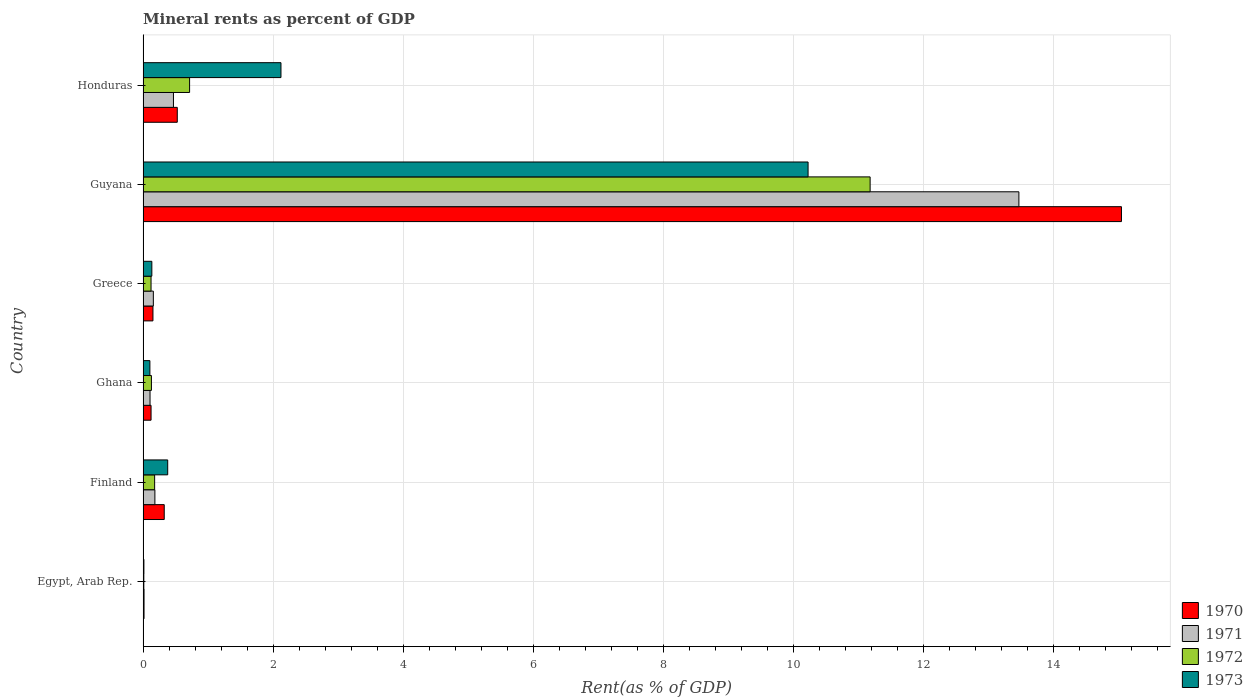How many groups of bars are there?
Make the answer very short. 6. Are the number of bars per tick equal to the number of legend labels?
Your response must be concise. Yes. How many bars are there on the 5th tick from the top?
Provide a short and direct response. 4. What is the label of the 5th group of bars from the top?
Provide a short and direct response. Finland. In how many cases, is the number of bars for a given country not equal to the number of legend labels?
Offer a very short reply. 0. What is the mineral rent in 1971 in Ghana?
Your response must be concise. 0.11. Across all countries, what is the maximum mineral rent in 1972?
Your response must be concise. 11.18. Across all countries, what is the minimum mineral rent in 1973?
Your answer should be very brief. 0.01. In which country was the mineral rent in 1970 maximum?
Ensure brevity in your answer.  Guyana. In which country was the mineral rent in 1970 minimum?
Offer a terse response. Egypt, Arab Rep. What is the total mineral rent in 1972 in the graph?
Your answer should be compact. 12.34. What is the difference between the mineral rent in 1972 in Finland and that in Guyana?
Provide a succinct answer. -11. What is the difference between the mineral rent in 1972 in Guyana and the mineral rent in 1973 in Honduras?
Offer a terse response. 9.06. What is the average mineral rent in 1971 per country?
Your answer should be very brief. 2.4. What is the difference between the mineral rent in 1972 and mineral rent in 1970 in Honduras?
Provide a succinct answer. 0.19. In how many countries, is the mineral rent in 1972 greater than 9.2 %?
Offer a very short reply. 1. What is the ratio of the mineral rent in 1970 in Egypt, Arab Rep. to that in Ghana?
Your answer should be compact. 0.12. Is the difference between the mineral rent in 1972 in Guyana and Honduras greater than the difference between the mineral rent in 1970 in Guyana and Honduras?
Keep it short and to the point. No. What is the difference between the highest and the second highest mineral rent in 1973?
Provide a succinct answer. 8.11. What is the difference between the highest and the lowest mineral rent in 1972?
Your answer should be compact. 11.17. Is it the case that in every country, the sum of the mineral rent in 1970 and mineral rent in 1971 is greater than the sum of mineral rent in 1973 and mineral rent in 1972?
Offer a terse response. No. Is it the case that in every country, the sum of the mineral rent in 1972 and mineral rent in 1971 is greater than the mineral rent in 1970?
Keep it short and to the point. Yes. Are all the bars in the graph horizontal?
Offer a very short reply. Yes. Does the graph contain any zero values?
Make the answer very short. No. What is the title of the graph?
Your answer should be compact. Mineral rents as percent of GDP. Does "1966" appear as one of the legend labels in the graph?
Keep it short and to the point. No. What is the label or title of the X-axis?
Your answer should be compact. Rent(as % of GDP). What is the Rent(as % of GDP) of 1970 in Egypt, Arab Rep.?
Ensure brevity in your answer.  0.01. What is the Rent(as % of GDP) in 1971 in Egypt, Arab Rep.?
Offer a very short reply. 0.02. What is the Rent(as % of GDP) in 1972 in Egypt, Arab Rep.?
Your answer should be compact. 0.01. What is the Rent(as % of GDP) in 1973 in Egypt, Arab Rep.?
Your response must be concise. 0.01. What is the Rent(as % of GDP) of 1970 in Finland?
Offer a terse response. 0.33. What is the Rent(as % of GDP) of 1971 in Finland?
Provide a succinct answer. 0.18. What is the Rent(as % of GDP) of 1972 in Finland?
Ensure brevity in your answer.  0.18. What is the Rent(as % of GDP) in 1973 in Finland?
Offer a very short reply. 0.38. What is the Rent(as % of GDP) of 1970 in Ghana?
Your answer should be compact. 0.12. What is the Rent(as % of GDP) of 1971 in Ghana?
Offer a terse response. 0.11. What is the Rent(as % of GDP) of 1972 in Ghana?
Offer a terse response. 0.13. What is the Rent(as % of GDP) in 1973 in Ghana?
Offer a terse response. 0.1. What is the Rent(as % of GDP) in 1970 in Greece?
Your answer should be compact. 0.15. What is the Rent(as % of GDP) of 1971 in Greece?
Offer a terse response. 0.16. What is the Rent(as % of GDP) of 1972 in Greece?
Keep it short and to the point. 0.12. What is the Rent(as % of GDP) of 1973 in Greece?
Your response must be concise. 0.13. What is the Rent(as % of GDP) in 1970 in Guyana?
Your answer should be compact. 15.05. What is the Rent(as % of GDP) of 1971 in Guyana?
Your answer should be very brief. 13.47. What is the Rent(as % of GDP) in 1972 in Guyana?
Your response must be concise. 11.18. What is the Rent(as % of GDP) of 1973 in Guyana?
Ensure brevity in your answer.  10.23. What is the Rent(as % of GDP) in 1970 in Honduras?
Your answer should be compact. 0.53. What is the Rent(as % of GDP) in 1971 in Honduras?
Provide a short and direct response. 0.47. What is the Rent(as % of GDP) of 1972 in Honduras?
Provide a short and direct response. 0.72. What is the Rent(as % of GDP) in 1973 in Honduras?
Give a very brief answer. 2.12. Across all countries, what is the maximum Rent(as % of GDP) of 1970?
Give a very brief answer. 15.05. Across all countries, what is the maximum Rent(as % of GDP) of 1971?
Provide a succinct answer. 13.47. Across all countries, what is the maximum Rent(as % of GDP) of 1972?
Provide a short and direct response. 11.18. Across all countries, what is the maximum Rent(as % of GDP) in 1973?
Offer a very short reply. 10.23. Across all countries, what is the minimum Rent(as % of GDP) in 1970?
Offer a terse response. 0.01. Across all countries, what is the minimum Rent(as % of GDP) in 1971?
Give a very brief answer. 0.02. Across all countries, what is the minimum Rent(as % of GDP) in 1972?
Provide a short and direct response. 0.01. Across all countries, what is the minimum Rent(as % of GDP) in 1973?
Offer a very short reply. 0.01. What is the total Rent(as % of GDP) of 1970 in the graph?
Offer a very short reply. 16.19. What is the total Rent(as % of GDP) of 1971 in the graph?
Offer a very short reply. 14.4. What is the total Rent(as % of GDP) of 1972 in the graph?
Give a very brief answer. 12.34. What is the total Rent(as % of GDP) in 1973 in the graph?
Ensure brevity in your answer.  12.98. What is the difference between the Rent(as % of GDP) in 1970 in Egypt, Arab Rep. and that in Finland?
Offer a terse response. -0.31. What is the difference between the Rent(as % of GDP) of 1971 in Egypt, Arab Rep. and that in Finland?
Offer a very short reply. -0.17. What is the difference between the Rent(as % of GDP) of 1972 in Egypt, Arab Rep. and that in Finland?
Give a very brief answer. -0.17. What is the difference between the Rent(as % of GDP) of 1973 in Egypt, Arab Rep. and that in Finland?
Your response must be concise. -0.37. What is the difference between the Rent(as % of GDP) in 1970 in Egypt, Arab Rep. and that in Ghana?
Your response must be concise. -0.11. What is the difference between the Rent(as % of GDP) of 1971 in Egypt, Arab Rep. and that in Ghana?
Provide a short and direct response. -0.09. What is the difference between the Rent(as % of GDP) in 1972 in Egypt, Arab Rep. and that in Ghana?
Provide a short and direct response. -0.12. What is the difference between the Rent(as % of GDP) in 1973 in Egypt, Arab Rep. and that in Ghana?
Make the answer very short. -0.09. What is the difference between the Rent(as % of GDP) in 1970 in Egypt, Arab Rep. and that in Greece?
Your answer should be compact. -0.14. What is the difference between the Rent(as % of GDP) in 1971 in Egypt, Arab Rep. and that in Greece?
Give a very brief answer. -0.14. What is the difference between the Rent(as % of GDP) in 1972 in Egypt, Arab Rep. and that in Greece?
Your response must be concise. -0.11. What is the difference between the Rent(as % of GDP) of 1973 in Egypt, Arab Rep. and that in Greece?
Make the answer very short. -0.12. What is the difference between the Rent(as % of GDP) in 1970 in Egypt, Arab Rep. and that in Guyana?
Provide a succinct answer. -15.03. What is the difference between the Rent(as % of GDP) of 1971 in Egypt, Arab Rep. and that in Guyana?
Ensure brevity in your answer.  -13.46. What is the difference between the Rent(as % of GDP) in 1972 in Egypt, Arab Rep. and that in Guyana?
Provide a short and direct response. -11.17. What is the difference between the Rent(as % of GDP) of 1973 in Egypt, Arab Rep. and that in Guyana?
Provide a short and direct response. -10.21. What is the difference between the Rent(as % of GDP) of 1970 in Egypt, Arab Rep. and that in Honduras?
Your response must be concise. -0.51. What is the difference between the Rent(as % of GDP) of 1971 in Egypt, Arab Rep. and that in Honduras?
Your answer should be compact. -0.45. What is the difference between the Rent(as % of GDP) in 1972 in Egypt, Arab Rep. and that in Honduras?
Provide a succinct answer. -0.7. What is the difference between the Rent(as % of GDP) in 1973 in Egypt, Arab Rep. and that in Honduras?
Provide a short and direct response. -2.11. What is the difference between the Rent(as % of GDP) in 1970 in Finland and that in Ghana?
Ensure brevity in your answer.  0.2. What is the difference between the Rent(as % of GDP) of 1971 in Finland and that in Ghana?
Keep it short and to the point. 0.07. What is the difference between the Rent(as % of GDP) of 1972 in Finland and that in Ghana?
Keep it short and to the point. 0.05. What is the difference between the Rent(as % of GDP) in 1973 in Finland and that in Ghana?
Provide a short and direct response. 0.27. What is the difference between the Rent(as % of GDP) of 1970 in Finland and that in Greece?
Provide a succinct answer. 0.17. What is the difference between the Rent(as % of GDP) of 1971 in Finland and that in Greece?
Make the answer very short. 0.02. What is the difference between the Rent(as % of GDP) in 1972 in Finland and that in Greece?
Your answer should be compact. 0.06. What is the difference between the Rent(as % of GDP) in 1973 in Finland and that in Greece?
Your response must be concise. 0.24. What is the difference between the Rent(as % of GDP) in 1970 in Finland and that in Guyana?
Offer a terse response. -14.72. What is the difference between the Rent(as % of GDP) in 1971 in Finland and that in Guyana?
Make the answer very short. -13.29. What is the difference between the Rent(as % of GDP) of 1972 in Finland and that in Guyana?
Keep it short and to the point. -11. What is the difference between the Rent(as % of GDP) of 1973 in Finland and that in Guyana?
Make the answer very short. -9.85. What is the difference between the Rent(as % of GDP) in 1970 in Finland and that in Honduras?
Provide a short and direct response. -0.2. What is the difference between the Rent(as % of GDP) of 1971 in Finland and that in Honduras?
Ensure brevity in your answer.  -0.29. What is the difference between the Rent(as % of GDP) in 1972 in Finland and that in Honduras?
Your response must be concise. -0.54. What is the difference between the Rent(as % of GDP) of 1973 in Finland and that in Honduras?
Keep it short and to the point. -1.74. What is the difference between the Rent(as % of GDP) of 1970 in Ghana and that in Greece?
Your answer should be very brief. -0.03. What is the difference between the Rent(as % of GDP) of 1971 in Ghana and that in Greece?
Provide a succinct answer. -0.05. What is the difference between the Rent(as % of GDP) in 1972 in Ghana and that in Greece?
Your answer should be very brief. 0.01. What is the difference between the Rent(as % of GDP) in 1973 in Ghana and that in Greece?
Give a very brief answer. -0.03. What is the difference between the Rent(as % of GDP) in 1970 in Ghana and that in Guyana?
Provide a short and direct response. -14.92. What is the difference between the Rent(as % of GDP) in 1971 in Ghana and that in Guyana?
Make the answer very short. -13.36. What is the difference between the Rent(as % of GDP) in 1972 in Ghana and that in Guyana?
Offer a terse response. -11.05. What is the difference between the Rent(as % of GDP) in 1973 in Ghana and that in Guyana?
Your answer should be very brief. -10.12. What is the difference between the Rent(as % of GDP) in 1970 in Ghana and that in Honduras?
Offer a very short reply. -0.4. What is the difference between the Rent(as % of GDP) in 1971 in Ghana and that in Honduras?
Ensure brevity in your answer.  -0.36. What is the difference between the Rent(as % of GDP) of 1972 in Ghana and that in Honduras?
Offer a very short reply. -0.59. What is the difference between the Rent(as % of GDP) in 1973 in Ghana and that in Honduras?
Make the answer very short. -2.02. What is the difference between the Rent(as % of GDP) of 1970 in Greece and that in Guyana?
Give a very brief answer. -14.9. What is the difference between the Rent(as % of GDP) of 1971 in Greece and that in Guyana?
Your answer should be very brief. -13.31. What is the difference between the Rent(as % of GDP) of 1972 in Greece and that in Guyana?
Keep it short and to the point. -11.06. What is the difference between the Rent(as % of GDP) in 1973 in Greece and that in Guyana?
Offer a terse response. -10.09. What is the difference between the Rent(as % of GDP) of 1970 in Greece and that in Honduras?
Keep it short and to the point. -0.37. What is the difference between the Rent(as % of GDP) of 1971 in Greece and that in Honduras?
Ensure brevity in your answer.  -0.31. What is the difference between the Rent(as % of GDP) of 1972 in Greece and that in Honduras?
Your answer should be very brief. -0.59. What is the difference between the Rent(as % of GDP) in 1973 in Greece and that in Honduras?
Your response must be concise. -1.99. What is the difference between the Rent(as % of GDP) in 1970 in Guyana and that in Honduras?
Offer a very short reply. 14.52. What is the difference between the Rent(as % of GDP) of 1971 in Guyana and that in Honduras?
Keep it short and to the point. 13. What is the difference between the Rent(as % of GDP) in 1972 in Guyana and that in Honduras?
Make the answer very short. 10.47. What is the difference between the Rent(as % of GDP) in 1973 in Guyana and that in Honduras?
Give a very brief answer. 8.11. What is the difference between the Rent(as % of GDP) in 1970 in Egypt, Arab Rep. and the Rent(as % of GDP) in 1971 in Finland?
Ensure brevity in your answer.  -0.17. What is the difference between the Rent(as % of GDP) in 1970 in Egypt, Arab Rep. and the Rent(as % of GDP) in 1972 in Finland?
Provide a short and direct response. -0.16. What is the difference between the Rent(as % of GDP) in 1970 in Egypt, Arab Rep. and the Rent(as % of GDP) in 1973 in Finland?
Make the answer very short. -0.36. What is the difference between the Rent(as % of GDP) of 1971 in Egypt, Arab Rep. and the Rent(as % of GDP) of 1972 in Finland?
Your answer should be very brief. -0.16. What is the difference between the Rent(as % of GDP) of 1971 in Egypt, Arab Rep. and the Rent(as % of GDP) of 1973 in Finland?
Offer a very short reply. -0.36. What is the difference between the Rent(as % of GDP) in 1972 in Egypt, Arab Rep. and the Rent(as % of GDP) in 1973 in Finland?
Give a very brief answer. -0.37. What is the difference between the Rent(as % of GDP) in 1970 in Egypt, Arab Rep. and the Rent(as % of GDP) in 1971 in Ghana?
Give a very brief answer. -0.09. What is the difference between the Rent(as % of GDP) of 1970 in Egypt, Arab Rep. and the Rent(as % of GDP) of 1972 in Ghana?
Your answer should be compact. -0.11. What is the difference between the Rent(as % of GDP) of 1970 in Egypt, Arab Rep. and the Rent(as % of GDP) of 1973 in Ghana?
Your response must be concise. -0.09. What is the difference between the Rent(as % of GDP) of 1971 in Egypt, Arab Rep. and the Rent(as % of GDP) of 1972 in Ghana?
Make the answer very short. -0.11. What is the difference between the Rent(as % of GDP) of 1971 in Egypt, Arab Rep. and the Rent(as % of GDP) of 1973 in Ghana?
Provide a succinct answer. -0.09. What is the difference between the Rent(as % of GDP) of 1972 in Egypt, Arab Rep. and the Rent(as % of GDP) of 1973 in Ghana?
Your response must be concise. -0.09. What is the difference between the Rent(as % of GDP) in 1970 in Egypt, Arab Rep. and the Rent(as % of GDP) in 1971 in Greece?
Provide a short and direct response. -0.14. What is the difference between the Rent(as % of GDP) of 1970 in Egypt, Arab Rep. and the Rent(as % of GDP) of 1972 in Greece?
Your answer should be compact. -0.11. What is the difference between the Rent(as % of GDP) of 1970 in Egypt, Arab Rep. and the Rent(as % of GDP) of 1973 in Greece?
Your answer should be compact. -0.12. What is the difference between the Rent(as % of GDP) in 1971 in Egypt, Arab Rep. and the Rent(as % of GDP) in 1972 in Greece?
Offer a terse response. -0.11. What is the difference between the Rent(as % of GDP) in 1971 in Egypt, Arab Rep. and the Rent(as % of GDP) in 1973 in Greece?
Your answer should be very brief. -0.12. What is the difference between the Rent(as % of GDP) of 1972 in Egypt, Arab Rep. and the Rent(as % of GDP) of 1973 in Greece?
Offer a very short reply. -0.12. What is the difference between the Rent(as % of GDP) in 1970 in Egypt, Arab Rep. and the Rent(as % of GDP) in 1971 in Guyana?
Keep it short and to the point. -13.46. What is the difference between the Rent(as % of GDP) of 1970 in Egypt, Arab Rep. and the Rent(as % of GDP) of 1972 in Guyana?
Your answer should be very brief. -11.17. What is the difference between the Rent(as % of GDP) in 1970 in Egypt, Arab Rep. and the Rent(as % of GDP) in 1973 in Guyana?
Ensure brevity in your answer.  -10.21. What is the difference between the Rent(as % of GDP) of 1971 in Egypt, Arab Rep. and the Rent(as % of GDP) of 1972 in Guyana?
Your answer should be compact. -11.17. What is the difference between the Rent(as % of GDP) of 1971 in Egypt, Arab Rep. and the Rent(as % of GDP) of 1973 in Guyana?
Give a very brief answer. -10.21. What is the difference between the Rent(as % of GDP) of 1972 in Egypt, Arab Rep. and the Rent(as % of GDP) of 1973 in Guyana?
Provide a succinct answer. -10.22. What is the difference between the Rent(as % of GDP) in 1970 in Egypt, Arab Rep. and the Rent(as % of GDP) in 1971 in Honduras?
Give a very brief answer. -0.45. What is the difference between the Rent(as % of GDP) in 1970 in Egypt, Arab Rep. and the Rent(as % of GDP) in 1972 in Honduras?
Your answer should be very brief. -0.7. What is the difference between the Rent(as % of GDP) in 1970 in Egypt, Arab Rep. and the Rent(as % of GDP) in 1973 in Honduras?
Give a very brief answer. -2.11. What is the difference between the Rent(as % of GDP) in 1971 in Egypt, Arab Rep. and the Rent(as % of GDP) in 1972 in Honduras?
Give a very brief answer. -0.7. What is the difference between the Rent(as % of GDP) of 1971 in Egypt, Arab Rep. and the Rent(as % of GDP) of 1973 in Honduras?
Your answer should be very brief. -2.11. What is the difference between the Rent(as % of GDP) in 1972 in Egypt, Arab Rep. and the Rent(as % of GDP) in 1973 in Honduras?
Give a very brief answer. -2.11. What is the difference between the Rent(as % of GDP) of 1970 in Finland and the Rent(as % of GDP) of 1971 in Ghana?
Keep it short and to the point. 0.22. What is the difference between the Rent(as % of GDP) of 1970 in Finland and the Rent(as % of GDP) of 1972 in Ghana?
Offer a terse response. 0.2. What is the difference between the Rent(as % of GDP) in 1970 in Finland and the Rent(as % of GDP) in 1973 in Ghana?
Provide a short and direct response. 0.22. What is the difference between the Rent(as % of GDP) in 1971 in Finland and the Rent(as % of GDP) in 1972 in Ghana?
Give a very brief answer. 0.05. What is the difference between the Rent(as % of GDP) of 1971 in Finland and the Rent(as % of GDP) of 1973 in Ghana?
Provide a succinct answer. 0.08. What is the difference between the Rent(as % of GDP) in 1972 in Finland and the Rent(as % of GDP) in 1973 in Ghana?
Your answer should be very brief. 0.07. What is the difference between the Rent(as % of GDP) in 1970 in Finland and the Rent(as % of GDP) in 1971 in Greece?
Keep it short and to the point. 0.17. What is the difference between the Rent(as % of GDP) of 1970 in Finland and the Rent(as % of GDP) of 1972 in Greece?
Keep it short and to the point. 0.2. What is the difference between the Rent(as % of GDP) in 1970 in Finland and the Rent(as % of GDP) in 1973 in Greece?
Keep it short and to the point. 0.19. What is the difference between the Rent(as % of GDP) in 1971 in Finland and the Rent(as % of GDP) in 1972 in Greece?
Provide a succinct answer. 0.06. What is the difference between the Rent(as % of GDP) in 1971 in Finland and the Rent(as % of GDP) in 1973 in Greece?
Give a very brief answer. 0.05. What is the difference between the Rent(as % of GDP) of 1972 in Finland and the Rent(as % of GDP) of 1973 in Greece?
Offer a terse response. 0.04. What is the difference between the Rent(as % of GDP) of 1970 in Finland and the Rent(as % of GDP) of 1971 in Guyana?
Keep it short and to the point. -13.14. What is the difference between the Rent(as % of GDP) of 1970 in Finland and the Rent(as % of GDP) of 1972 in Guyana?
Give a very brief answer. -10.86. What is the difference between the Rent(as % of GDP) of 1970 in Finland and the Rent(as % of GDP) of 1973 in Guyana?
Provide a succinct answer. -9.9. What is the difference between the Rent(as % of GDP) of 1971 in Finland and the Rent(as % of GDP) of 1972 in Guyana?
Offer a very short reply. -11. What is the difference between the Rent(as % of GDP) in 1971 in Finland and the Rent(as % of GDP) in 1973 in Guyana?
Your response must be concise. -10.05. What is the difference between the Rent(as % of GDP) in 1972 in Finland and the Rent(as % of GDP) in 1973 in Guyana?
Offer a terse response. -10.05. What is the difference between the Rent(as % of GDP) in 1970 in Finland and the Rent(as % of GDP) in 1971 in Honduras?
Provide a short and direct response. -0.14. What is the difference between the Rent(as % of GDP) of 1970 in Finland and the Rent(as % of GDP) of 1972 in Honduras?
Keep it short and to the point. -0.39. What is the difference between the Rent(as % of GDP) of 1970 in Finland and the Rent(as % of GDP) of 1973 in Honduras?
Your answer should be very brief. -1.8. What is the difference between the Rent(as % of GDP) in 1971 in Finland and the Rent(as % of GDP) in 1972 in Honduras?
Keep it short and to the point. -0.53. What is the difference between the Rent(as % of GDP) in 1971 in Finland and the Rent(as % of GDP) in 1973 in Honduras?
Your answer should be very brief. -1.94. What is the difference between the Rent(as % of GDP) of 1972 in Finland and the Rent(as % of GDP) of 1973 in Honduras?
Your answer should be very brief. -1.94. What is the difference between the Rent(as % of GDP) in 1970 in Ghana and the Rent(as % of GDP) in 1971 in Greece?
Your response must be concise. -0.04. What is the difference between the Rent(as % of GDP) in 1970 in Ghana and the Rent(as % of GDP) in 1972 in Greece?
Give a very brief answer. 0. What is the difference between the Rent(as % of GDP) in 1970 in Ghana and the Rent(as % of GDP) in 1973 in Greece?
Give a very brief answer. -0.01. What is the difference between the Rent(as % of GDP) in 1971 in Ghana and the Rent(as % of GDP) in 1972 in Greece?
Provide a succinct answer. -0.02. What is the difference between the Rent(as % of GDP) of 1971 in Ghana and the Rent(as % of GDP) of 1973 in Greece?
Keep it short and to the point. -0.03. What is the difference between the Rent(as % of GDP) of 1972 in Ghana and the Rent(as % of GDP) of 1973 in Greece?
Make the answer very short. -0.01. What is the difference between the Rent(as % of GDP) of 1970 in Ghana and the Rent(as % of GDP) of 1971 in Guyana?
Provide a succinct answer. -13.35. What is the difference between the Rent(as % of GDP) of 1970 in Ghana and the Rent(as % of GDP) of 1972 in Guyana?
Keep it short and to the point. -11.06. What is the difference between the Rent(as % of GDP) of 1970 in Ghana and the Rent(as % of GDP) of 1973 in Guyana?
Ensure brevity in your answer.  -10.1. What is the difference between the Rent(as % of GDP) in 1971 in Ghana and the Rent(as % of GDP) in 1972 in Guyana?
Provide a succinct answer. -11.07. What is the difference between the Rent(as % of GDP) of 1971 in Ghana and the Rent(as % of GDP) of 1973 in Guyana?
Your answer should be compact. -10.12. What is the difference between the Rent(as % of GDP) of 1972 in Ghana and the Rent(as % of GDP) of 1973 in Guyana?
Offer a very short reply. -10.1. What is the difference between the Rent(as % of GDP) of 1970 in Ghana and the Rent(as % of GDP) of 1971 in Honduras?
Your answer should be compact. -0.34. What is the difference between the Rent(as % of GDP) in 1970 in Ghana and the Rent(as % of GDP) in 1972 in Honduras?
Ensure brevity in your answer.  -0.59. What is the difference between the Rent(as % of GDP) of 1970 in Ghana and the Rent(as % of GDP) of 1973 in Honduras?
Give a very brief answer. -2. What is the difference between the Rent(as % of GDP) of 1971 in Ghana and the Rent(as % of GDP) of 1972 in Honduras?
Your response must be concise. -0.61. What is the difference between the Rent(as % of GDP) of 1971 in Ghana and the Rent(as % of GDP) of 1973 in Honduras?
Give a very brief answer. -2.01. What is the difference between the Rent(as % of GDP) of 1972 in Ghana and the Rent(as % of GDP) of 1973 in Honduras?
Give a very brief answer. -1.99. What is the difference between the Rent(as % of GDP) of 1970 in Greece and the Rent(as % of GDP) of 1971 in Guyana?
Ensure brevity in your answer.  -13.32. What is the difference between the Rent(as % of GDP) in 1970 in Greece and the Rent(as % of GDP) in 1972 in Guyana?
Provide a short and direct response. -11.03. What is the difference between the Rent(as % of GDP) of 1970 in Greece and the Rent(as % of GDP) of 1973 in Guyana?
Keep it short and to the point. -10.08. What is the difference between the Rent(as % of GDP) of 1971 in Greece and the Rent(as % of GDP) of 1972 in Guyana?
Offer a terse response. -11.02. What is the difference between the Rent(as % of GDP) of 1971 in Greece and the Rent(as % of GDP) of 1973 in Guyana?
Your response must be concise. -10.07. What is the difference between the Rent(as % of GDP) in 1972 in Greece and the Rent(as % of GDP) in 1973 in Guyana?
Keep it short and to the point. -10.1. What is the difference between the Rent(as % of GDP) of 1970 in Greece and the Rent(as % of GDP) of 1971 in Honduras?
Keep it short and to the point. -0.32. What is the difference between the Rent(as % of GDP) in 1970 in Greece and the Rent(as % of GDP) in 1972 in Honduras?
Provide a succinct answer. -0.56. What is the difference between the Rent(as % of GDP) in 1970 in Greece and the Rent(as % of GDP) in 1973 in Honduras?
Your response must be concise. -1.97. What is the difference between the Rent(as % of GDP) of 1971 in Greece and the Rent(as % of GDP) of 1972 in Honduras?
Offer a terse response. -0.56. What is the difference between the Rent(as % of GDP) in 1971 in Greece and the Rent(as % of GDP) in 1973 in Honduras?
Provide a succinct answer. -1.96. What is the difference between the Rent(as % of GDP) in 1972 in Greece and the Rent(as % of GDP) in 1973 in Honduras?
Provide a short and direct response. -2. What is the difference between the Rent(as % of GDP) of 1970 in Guyana and the Rent(as % of GDP) of 1971 in Honduras?
Your response must be concise. 14.58. What is the difference between the Rent(as % of GDP) in 1970 in Guyana and the Rent(as % of GDP) in 1972 in Honduras?
Offer a very short reply. 14.33. What is the difference between the Rent(as % of GDP) of 1970 in Guyana and the Rent(as % of GDP) of 1973 in Honduras?
Make the answer very short. 12.93. What is the difference between the Rent(as % of GDP) in 1971 in Guyana and the Rent(as % of GDP) in 1972 in Honduras?
Offer a terse response. 12.75. What is the difference between the Rent(as % of GDP) in 1971 in Guyana and the Rent(as % of GDP) in 1973 in Honduras?
Your answer should be very brief. 11.35. What is the difference between the Rent(as % of GDP) of 1972 in Guyana and the Rent(as % of GDP) of 1973 in Honduras?
Your response must be concise. 9.06. What is the average Rent(as % of GDP) of 1970 per country?
Give a very brief answer. 2.7. What is the average Rent(as % of GDP) of 1971 per country?
Keep it short and to the point. 2.4. What is the average Rent(as % of GDP) of 1972 per country?
Offer a terse response. 2.06. What is the average Rent(as % of GDP) of 1973 per country?
Your response must be concise. 2.16. What is the difference between the Rent(as % of GDP) of 1970 and Rent(as % of GDP) of 1971 in Egypt, Arab Rep.?
Ensure brevity in your answer.  -0. What is the difference between the Rent(as % of GDP) of 1970 and Rent(as % of GDP) of 1972 in Egypt, Arab Rep.?
Offer a terse response. 0. What is the difference between the Rent(as % of GDP) of 1970 and Rent(as % of GDP) of 1973 in Egypt, Arab Rep.?
Keep it short and to the point. 0. What is the difference between the Rent(as % of GDP) in 1971 and Rent(as % of GDP) in 1972 in Egypt, Arab Rep.?
Offer a terse response. 0. What is the difference between the Rent(as % of GDP) of 1971 and Rent(as % of GDP) of 1973 in Egypt, Arab Rep.?
Make the answer very short. 0. What is the difference between the Rent(as % of GDP) in 1972 and Rent(as % of GDP) in 1973 in Egypt, Arab Rep.?
Keep it short and to the point. -0. What is the difference between the Rent(as % of GDP) of 1970 and Rent(as % of GDP) of 1971 in Finland?
Keep it short and to the point. 0.14. What is the difference between the Rent(as % of GDP) in 1970 and Rent(as % of GDP) in 1972 in Finland?
Keep it short and to the point. 0.15. What is the difference between the Rent(as % of GDP) in 1970 and Rent(as % of GDP) in 1973 in Finland?
Ensure brevity in your answer.  -0.05. What is the difference between the Rent(as % of GDP) of 1971 and Rent(as % of GDP) of 1972 in Finland?
Give a very brief answer. 0. What is the difference between the Rent(as % of GDP) of 1971 and Rent(as % of GDP) of 1973 in Finland?
Offer a very short reply. -0.2. What is the difference between the Rent(as % of GDP) in 1972 and Rent(as % of GDP) in 1973 in Finland?
Offer a very short reply. -0.2. What is the difference between the Rent(as % of GDP) in 1970 and Rent(as % of GDP) in 1971 in Ghana?
Offer a terse response. 0.02. What is the difference between the Rent(as % of GDP) of 1970 and Rent(as % of GDP) of 1972 in Ghana?
Offer a very short reply. -0.01. What is the difference between the Rent(as % of GDP) of 1970 and Rent(as % of GDP) of 1973 in Ghana?
Provide a succinct answer. 0.02. What is the difference between the Rent(as % of GDP) in 1971 and Rent(as % of GDP) in 1972 in Ghana?
Your answer should be compact. -0.02. What is the difference between the Rent(as % of GDP) of 1971 and Rent(as % of GDP) of 1973 in Ghana?
Provide a short and direct response. 0. What is the difference between the Rent(as % of GDP) of 1972 and Rent(as % of GDP) of 1973 in Ghana?
Offer a terse response. 0.02. What is the difference between the Rent(as % of GDP) of 1970 and Rent(as % of GDP) of 1971 in Greece?
Your answer should be compact. -0.01. What is the difference between the Rent(as % of GDP) of 1970 and Rent(as % of GDP) of 1972 in Greece?
Keep it short and to the point. 0.03. What is the difference between the Rent(as % of GDP) in 1970 and Rent(as % of GDP) in 1973 in Greece?
Ensure brevity in your answer.  0.02. What is the difference between the Rent(as % of GDP) of 1971 and Rent(as % of GDP) of 1972 in Greece?
Make the answer very short. 0.04. What is the difference between the Rent(as % of GDP) in 1971 and Rent(as % of GDP) in 1973 in Greece?
Offer a terse response. 0.02. What is the difference between the Rent(as % of GDP) of 1972 and Rent(as % of GDP) of 1973 in Greece?
Make the answer very short. -0.01. What is the difference between the Rent(as % of GDP) in 1970 and Rent(as % of GDP) in 1971 in Guyana?
Your response must be concise. 1.58. What is the difference between the Rent(as % of GDP) in 1970 and Rent(as % of GDP) in 1972 in Guyana?
Offer a very short reply. 3.87. What is the difference between the Rent(as % of GDP) of 1970 and Rent(as % of GDP) of 1973 in Guyana?
Your response must be concise. 4.82. What is the difference between the Rent(as % of GDP) of 1971 and Rent(as % of GDP) of 1972 in Guyana?
Your response must be concise. 2.29. What is the difference between the Rent(as % of GDP) of 1971 and Rent(as % of GDP) of 1973 in Guyana?
Your answer should be compact. 3.24. What is the difference between the Rent(as % of GDP) in 1972 and Rent(as % of GDP) in 1973 in Guyana?
Your response must be concise. 0.95. What is the difference between the Rent(as % of GDP) of 1970 and Rent(as % of GDP) of 1971 in Honduras?
Your response must be concise. 0.06. What is the difference between the Rent(as % of GDP) in 1970 and Rent(as % of GDP) in 1972 in Honduras?
Provide a succinct answer. -0.19. What is the difference between the Rent(as % of GDP) in 1970 and Rent(as % of GDP) in 1973 in Honduras?
Keep it short and to the point. -1.59. What is the difference between the Rent(as % of GDP) in 1971 and Rent(as % of GDP) in 1972 in Honduras?
Give a very brief answer. -0.25. What is the difference between the Rent(as % of GDP) of 1971 and Rent(as % of GDP) of 1973 in Honduras?
Ensure brevity in your answer.  -1.65. What is the difference between the Rent(as % of GDP) of 1972 and Rent(as % of GDP) of 1973 in Honduras?
Keep it short and to the point. -1.41. What is the ratio of the Rent(as % of GDP) in 1970 in Egypt, Arab Rep. to that in Finland?
Give a very brief answer. 0.05. What is the ratio of the Rent(as % of GDP) in 1971 in Egypt, Arab Rep. to that in Finland?
Make the answer very short. 0.08. What is the ratio of the Rent(as % of GDP) of 1972 in Egypt, Arab Rep. to that in Finland?
Provide a succinct answer. 0.07. What is the ratio of the Rent(as % of GDP) of 1973 in Egypt, Arab Rep. to that in Finland?
Offer a very short reply. 0.03. What is the ratio of the Rent(as % of GDP) in 1970 in Egypt, Arab Rep. to that in Ghana?
Your answer should be very brief. 0.12. What is the ratio of the Rent(as % of GDP) of 1971 in Egypt, Arab Rep. to that in Ghana?
Your response must be concise. 0.14. What is the ratio of the Rent(as % of GDP) of 1972 in Egypt, Arab Rep. to that in Ghana?
Provide a short and direct response. 0.09. What is the ratio of the Rent(as % of GDP) of 1973 in Egypt, Arab Rep. to that in Ghana?
Keep it short and to the point. 0.12. What is the ratio of the Rent(as % of GDP) in 1970 in Egypt, Arab Rep. to that in Greece?
Ensure brevity in your answer.  0.1. What is the ratio of the Rent(as % of GDP) in 1971 in Egypt, Arab Rep. to that in Greece?
Offer a terse response. 0.1. What is the ratio of the Rent(as % of GDP) of 1972 in Egypt, Arab Rep. to that in Greece?
Keep it short and to the point. 0.1. What is the ratio of the Rent(as % of GDP) in 1973 in Egypt, Arab Rep. to that in Greece?
Keep it short and to the point. 0.1. What is the ratio of the Rent(as % of GDP) in 1970 in Egypt, Arab Rep. to that in Guyana?
Offer a very short reply. 0. What is the ratio of the Rent(as % of GDP) in 1971 in Egypt, Arab Rep. to that in Guyana?
Offer a terse response. 0. What is the ratio of the Rent(as % of GDP) of 1973 in Egypt, Arab Rep. to that in Guyana?
Keep it short and to the point. 0. What is the ratio of the Rent(as % of GDP) in 1970 in Egypt, Arab Rep. to that in Honduras?
Provide a short and direct response. 0.03. What is the ratio of the Rent(as % of GDP) of 1971 in Egypt, Arab Rep. to that in Honduras?
Ensure brevity in your answer.  0.03. What is the ratio of the Rent(as % of GDP) in 1972 in Egypt, Arab Rep. to that in Honduras?
Your response must be concise. 0.02. What is the ratio of the Rent(as % of GDP) in 1973 in Egypt, Arab Rep. to that in Honduras?
Your response must be concise. 0.01. What is the ratio of the Rent(as % of GDP) of 1970 in Finland to that in Ghana?
Your answer should be very brief. 2.65. What is the ratio of the Rent(as % of GDP) of 1971 in Finland to that in Ghana?
Your response must be concise. 1.7. What is the ratio of the Rent(as % of GDP) of 1972 in Finland to that in Ghana?
Your answer should be very brief. 1.38. What is the ratio of the Rent(as % of GDP) in 1973 in Finland to that in Ghana?
Offer a very short reply. 3.61. What is the ratio of the Rent(as % of GDP) of 1970 in Finland to that in Greece?
Make the answer very short. 2.14. What is the ratio of the Rent(as % of GDP) in 1971 in Finland to that in Greece?
Give a very brief answer. 1.15. What is the ratio of the Rent(as % of GDP) in 1972 in Finland to that in Greece?
Ensure brevity in your answer.  1.45. What is the ratio of the Rent(as % of GDP) of 1973 in Finland to that in Greece?
Provide a succinct answer. 2.81. What is the ratio of the Rent(as % of GDP) of 1970 in Finland to that in Guyana?
Keep it short and to the point. 0.02. What is the ratio of the Rent(as % of GDP) of 1971 in Finland to that in Guyana?
Keep it short and to the point. 0.01. What is the ratio of the Rent(as % of GDP) of 1972 in Finland to that in Guyana?
Your answer should be very brief. 0.02. What is the ratio of the Rent(as % of GDP) of 1973 in Finland to that in Guyana?
Your answer should be compact. 0.04. What is the ratio of the Rent(as % of GDP) in 1970 in Finland to that in Honduras?
Your answer should be very brief. 0.62. What is the ratio of the Rent(as % of GDP) of 1971 in Finland to that in Honduras?
Ensure brevity in your answer.  0.39. What is the ratio of the Rent(as % of GDP) in 1972 in Finland to that in Honduras?
Your answer should be very brief. 0.25. What is the ratio of the Rent(as % of GDP) of 1973 in Finland to that in Honduras?
Make the answer very short. 0.18. What is the ratio of the Rent(as % of GDP) of 1970 in Ghana to that in Greece?
Keep it short and to the point. 0.81. What is the ratio of the Rent(as % of GDP) of 1971 in Ghana to that in Greece?
Give a very brief answer. 0.68. What is the ratio of the Rent(as % of GDP) in 1972 in Ghana to that in Greece?
Ensure brevity in your answer.  1.05. What is the ratio of the Rent(as % of GDP) in 1973 in Ghana to that in Greece?
Ensure brevity in your answer.  0.78. What is the ratio of the Rent(as % of GDP) of 1970 in Ghana to that in Guyana?
Your answer should be very brief. 0.01. What is the ratio of the Rent(as % of GDP) of 1971 in Ghana to that in Guyana?
Your answer should be very brief. 0.01. What is the ratio of the Rent(as % of GDP) of 1972 in Ghana to that in Guyana?
Provide a short and direct response. 0.01. What is the ratio of the Rent(as % of GDP) of 1973 in Ghana to that in Guyana?
Offer a very short reply. 0.01. What is the ratio of the Rent(as % of GDP) of 1970 in Ghana to that in Honduras?
Provide a succinct answer. 0.23. What is the ratio of the Rent(as % of GDP) of 1971 in Ghana to that in Honduras?
Provide a succinct answer. 0.23. What is the ratio of the Rent(as % of GDP) in 1972 in Ghana to that in Honduras?
Keep it short and to the point. 0.18. What is the ratio of the Rent(as % of GDP) in 1973 in Ghana to that in Honduras?
Your answer should be very brief. 0.05. What is the ratio of the Rent(as % of GDP) in 1970 in Greece to that in Guyana?
Your response must be concise. 0.01. What is the ratio of the Rent(as % of GDP) in 1971 in Greece to that in Guyana?
Ensure brevity in your answer.  0.01. What is the ratio of the Rent(as % of GDP) in 1972 in Greece to that in Guyana?
Your response must be concise. 0.01. What is the ratio of the Rent(as % of GDP) in 1973 in Greece to that in Guyana?
Provide a short and direct response. 0.01. What is the ratio of the Rent(as % of GDP) in 1970 in Greece to that in Honduras?
Keep it short and to the point. 0.29. What is the ratio of the Rent(as % of GDP) of 1971 in Greece to that in Honduras?
Your answer should be compact. 0.34. What is the ratio of the Rent(as % of GDP) in 1972 in Greece to that in Honduras?
Your answer should be compact. 0.17. What is the ratio of the Rent(as % of GDP) of 1973 in Greece to that in Honduras?
Ensure brevity in your answer.  0.06. What is the ratio of the Rent(as % of GDP) of 1970 in Guyana to that in Honduras?
Make the answer very short. 28.59. What is the ratio of the Rent(as % of GDP) of 1971 in Guyana to that in Honduras?
Your answer should be very brief. 28.82. What is the ratio of the Rent(as % of GDP) of 1972 in Guyana to that in Honduras?
Provide a short and direct response. 15.63. What is the ratio of the Rent(as % of GDP) of 1973 in Guyana to that in Honduras?
Offer a very short reply. 4.82. What is the difference between the highest and the second highest Rent(as % of GDP) in 1970?
Provide a succinct answer. 14.52. What is the difference between the highest and the second highest Rent(as % of GDP) in 1971?
Your answer should be compact. 13. What is the difference between the highest and the second highest Rent(as % of GDP) in 1972?
Make the answer very short. 10.47. What is the difference between the highest and the second highest Rent(as % of GDP) in 1973?
Ensure brevity in your answer.  8.11. What is the difference between the highest and the lowest Rent(as % of GDP) of 1970?
Provide a short and direct response. 15.03. What is the difference between the highest and the lowest Rent(as % of GDP) of 1971?
Your response must be concise. 13.46. What is the difference between the highest and the lowest Rent(as % of GDP) of 1972?
Provide a succinct answer. 11.17. What is the difference between the highest and the lowest Rent(as % of GDP) of 1973?
Provide a succinct answer. 10.21. 